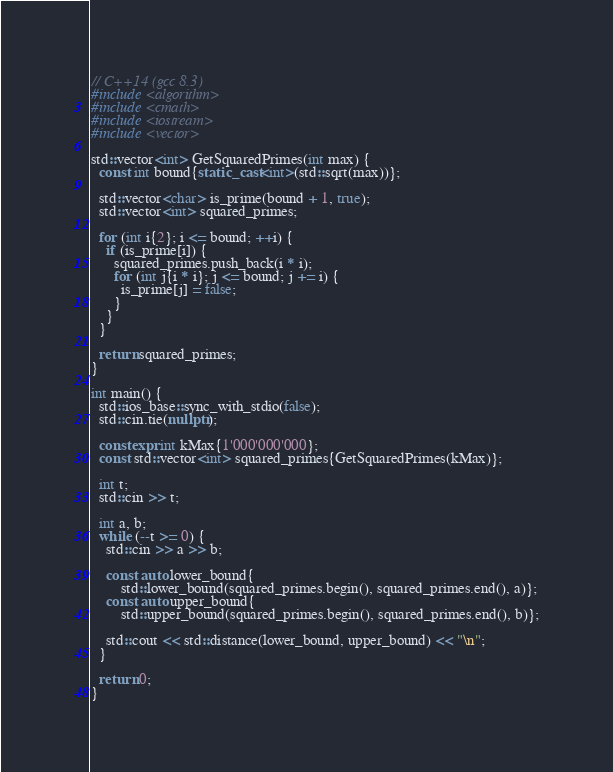Convert code to text. <code><loc_0><loc_0><loc_500><loc_500><_C++_>// C++14 (gcc 8.3)
#include <algorithm>
#include <cmath>
#include <iostream>
#include <vector>

std::vector<int> GetSquaredPrimes(int max) {
  const int bound{static_cast<int>(std::sqrt(max))};

  std::vector<char> is_prime(bound + 1, true);
  std::vector<int> squared_primes;

  for (int i{2}; i <= bound; ++i) {
    if (is_prime[i]) {
      squared_primes.push_back(i * i);
      for (int j{i * i}; j <= bound; j += i) {
        is_prime[j] = false;
      }
    }
  }

  return squared_primes;
}

int main() {
  std::ios_base::sync_with_stdio(false);
  std::cin.tie(nullptr);

  constexpr int kMax{1'000'000'000};
  const std::vector<int> squared_primes{GetSquaredPrimes(kMax)};

  int t;
  std::cin >> t;

  int a, b;
  while (--t >= 0) {
    std::cin >> a >> b;

    const auto lower_bound{
        std::lower_bound(squared_primes.begin(), squared_primes.end(), a)};
    const auto upper_bound{
        std::upper_bound(squared_primes.begin(), squared_primes.end(), b)};

    std::cout << std::distance(lower_bound, upper_bound) << "\n";
  }

  return 0;
}</code> 